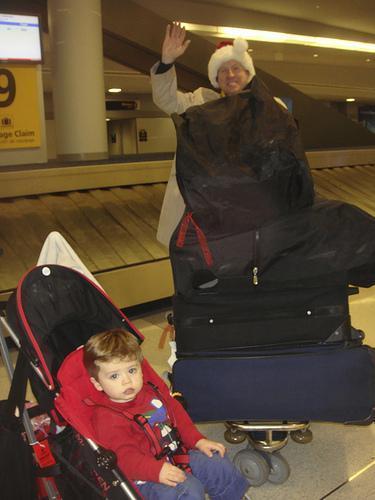How many people are in the photo?
Give a very brief answer. 2. 